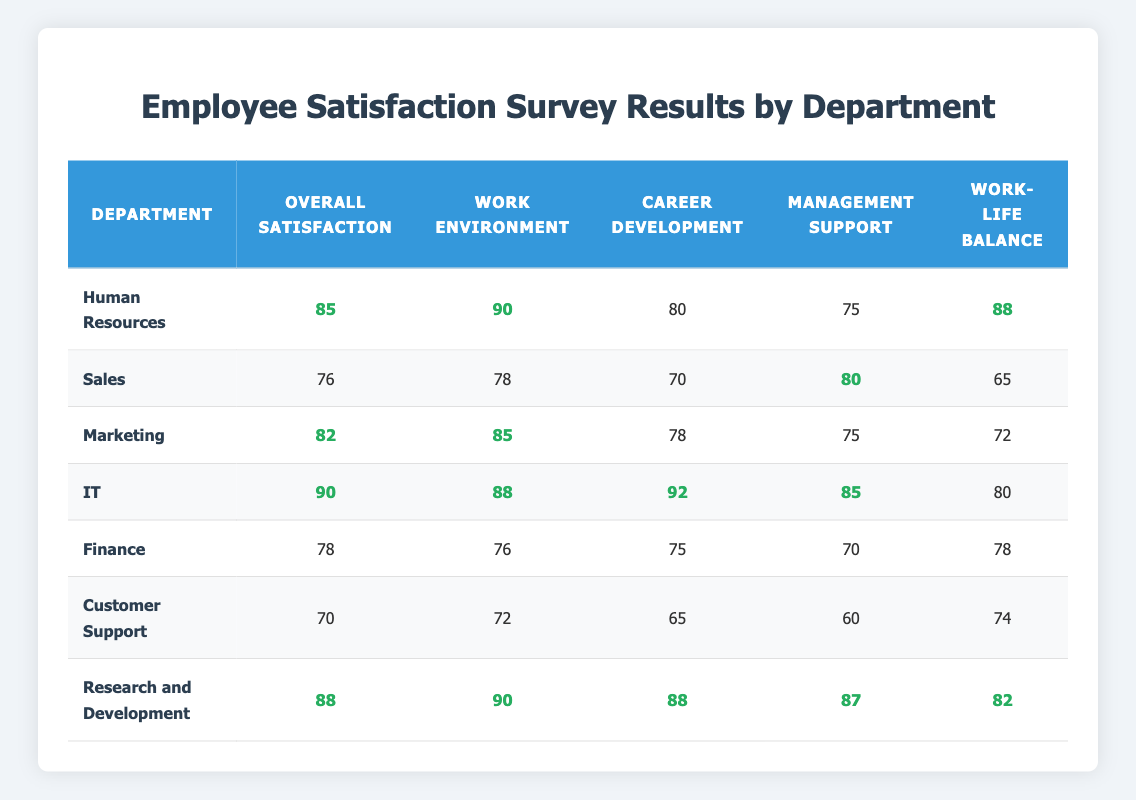What's the overall satisfaction score for the IT department? The table shows that the IT department has an overall satisfaction score of **90**.
Answer: 90 Which department has the highest work environment score? The highest work environment score is **90**, which belongs to both the Human Resources and Research and Development departments.
Answer: Human Resources and Research and Development What is the career development satisfaction score for Sales? From the table, it can be seen that the career development satisfaction score for the Sales department is **70**.
Answer: 70 Which department reports the lowest overall satisfaction? By reviewing the overall satisfaction scores in the table, the Customer Support department has the lowest score of **70**.
Answer: Customer Support What is the average work-life balance score across all departments? The work-life balance scores are **88, 65, 72, 80, 78, 74, 82**. The total is (88 + 65 + 72 + 80 + 78 + 74 + 82) = 539. There are 7 departments, so the average is 539/7 ≈ **77**.
Answer: 77 Is the management support score for Marketing higher than that for Finance? The table indicates Marketing has a management support score of **75**, while Finance has **70**. Since **75** is greater than **70**, the statement is true.
Answer: Yes What is the difference between the overall satisfaction scores of IT and Customer Support? The overall satisfaction for IT is **90**, and for Customer Support, it is **70**. The difference is 90 - 70 = **20**.
Answer: 20 Which department has a career development score equal to or greater than 80? The departments with career development scores are: Human Resources (80), IT (92), and Research and Development (88). All these scores are equal to or greater than **80**.
Answer: Human Resources, IT, Research and Development What is the sum of the work environment scores for the Human Resources and IT departments? The work environment scores are **90** for Human Resources and **88** for IT. Adding these scores gives 90 + 88 = **178**.
Answer: 178 Is the overall satisfaction score for Research and Development greater than the average of all departments? The overall satisfaction for Research and Development is **88**. The average satisfaction score for all departments is (85 + 76 + 82 + 90 + 78 + 70 + 88) / 7 = 79. The comparison shows 88 > 79.
Answer: Yes 